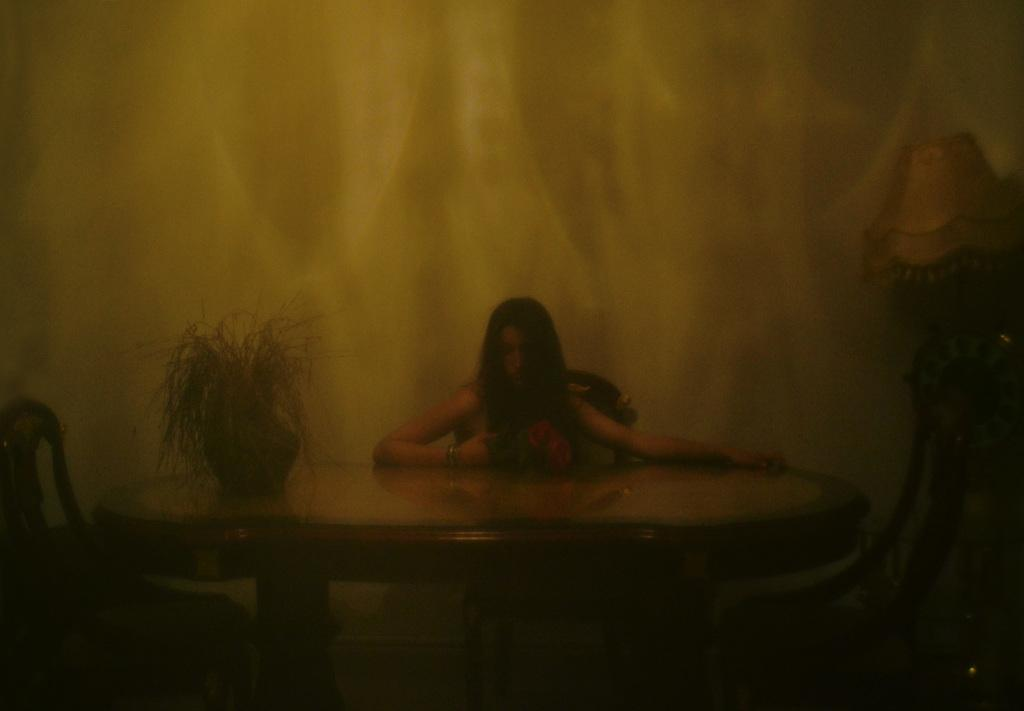What is the girl doing in the image? The girl is sitting on a chair in the image. What is in front of the girl? The girl is in front of a table. What is on the table? There is a plant on the table. What can be seen on the right side of the image? There is a lamp on the right side of the image. How many chairs are visible in the image? There are two more chairs in the image, in addition to the one the girl is sitting on. What type of alarm is the girl thinking about in the image? There is no indication in the image that the girl is thinking about an alarm. 